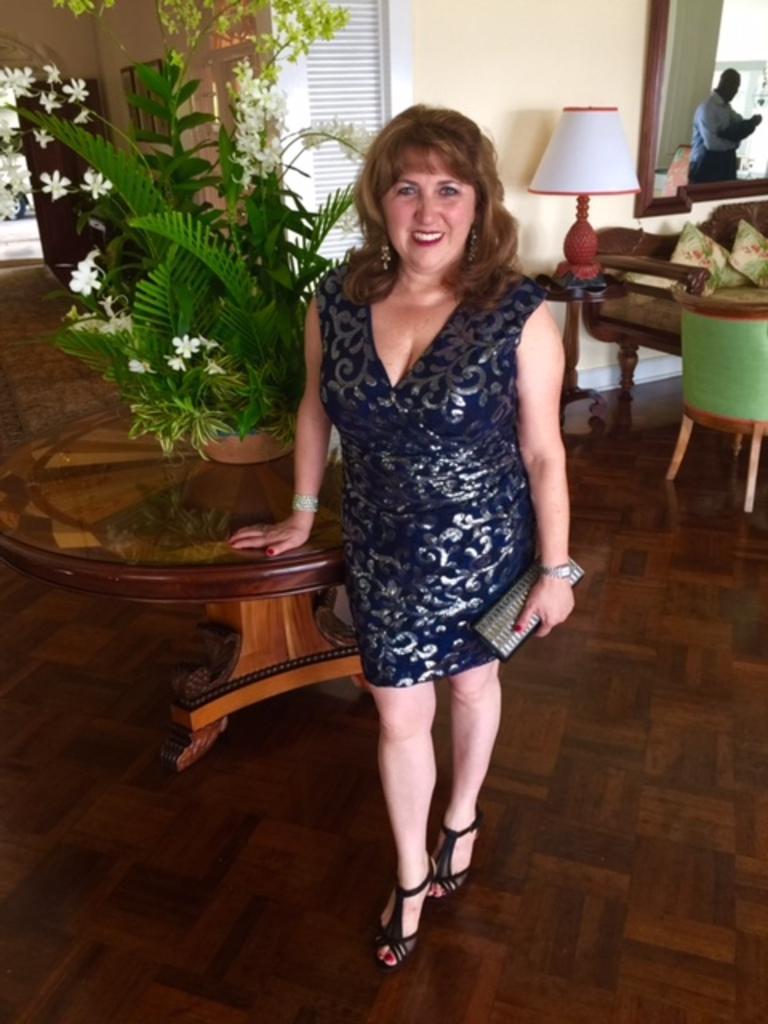Describe this image in one or two sentences. In the foreground, a woman is standing and holding a purse in her hand and having a smile on her face. Next to that a houseplant is there on the table. In the right sofa is there on which cushions are kept and a lamp is there on the table next to it. The walls are of light cream in color and a window is visible and a mirror is visible in the right and doors are visible. This image is taken inside a house. 